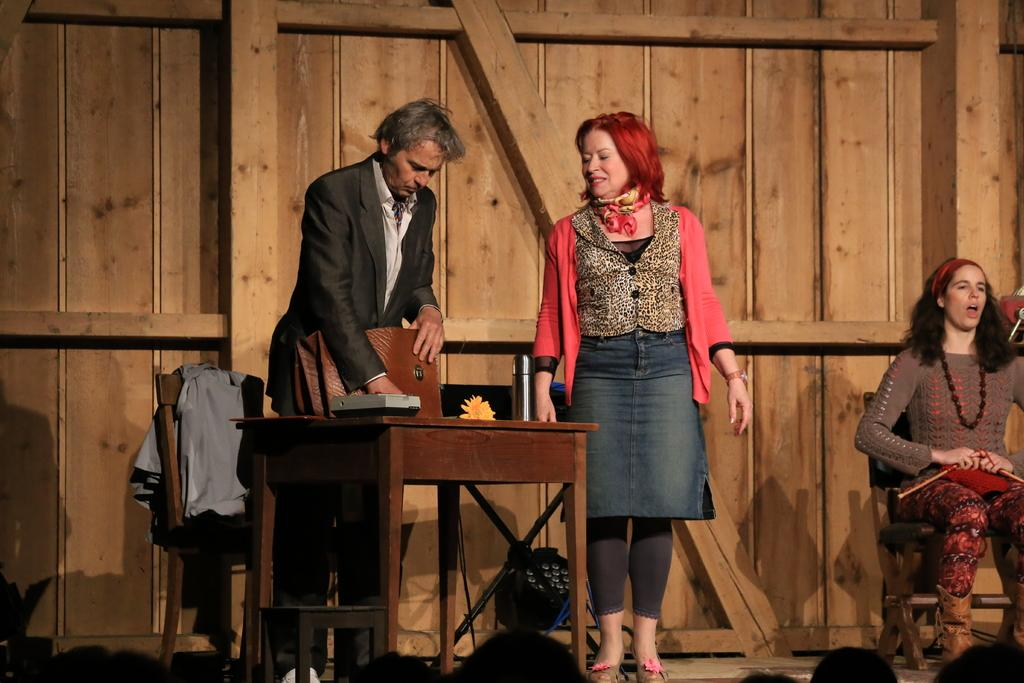What is the woman in the image doing? The woman is sitting on a chair and speaking on a microphone. Where is the woman located in the image? The woman is on the right side of the image. What else can be seen in the image besides the woman? There are two people standing in the center of the image. What type of cake is being served to the woman in the image? There is no cake present in the image; the woman is speaking on a microphone. What kind of approval does the woman need to continue speaking in the image? There is no indication in the image that the woman needs any approval to continue speaking. 